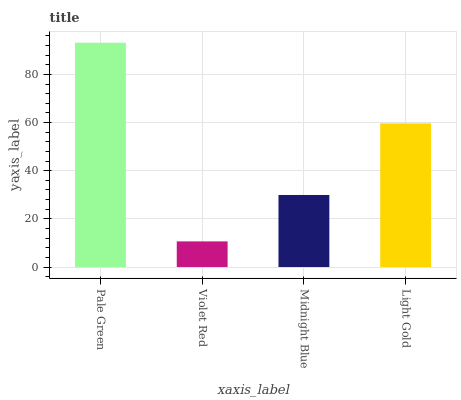Is Violet Red the minimum?
Answer yes or no. Yes. Is Pale Green the maximum?
Answer yes or no. Yes. Is Midnight Blue the minimum?
Answer yes or no. No. Is Midnight Blue the maximum?
Answer yes or no. No. Is Midnight Blue greater than Violet Red?
Answer yes or no. Yes. Is Violet Red less than Midnight Blue?
Answer yes or no. Yes. Is Violet Red greater than Midnight Blue?
Answer yes or no. No. Is Midnight Blue less than Violet Red?
Answer yes or no. No. Is Light Gold the high median?
Answer yes or no. Yes. Is Midnight Blue the low median?
Answer yes or no. Yes. Is Pale Green the high median?
Answer yes or no. No. Is Light Gold the low median?
Answer yes or no. No. 